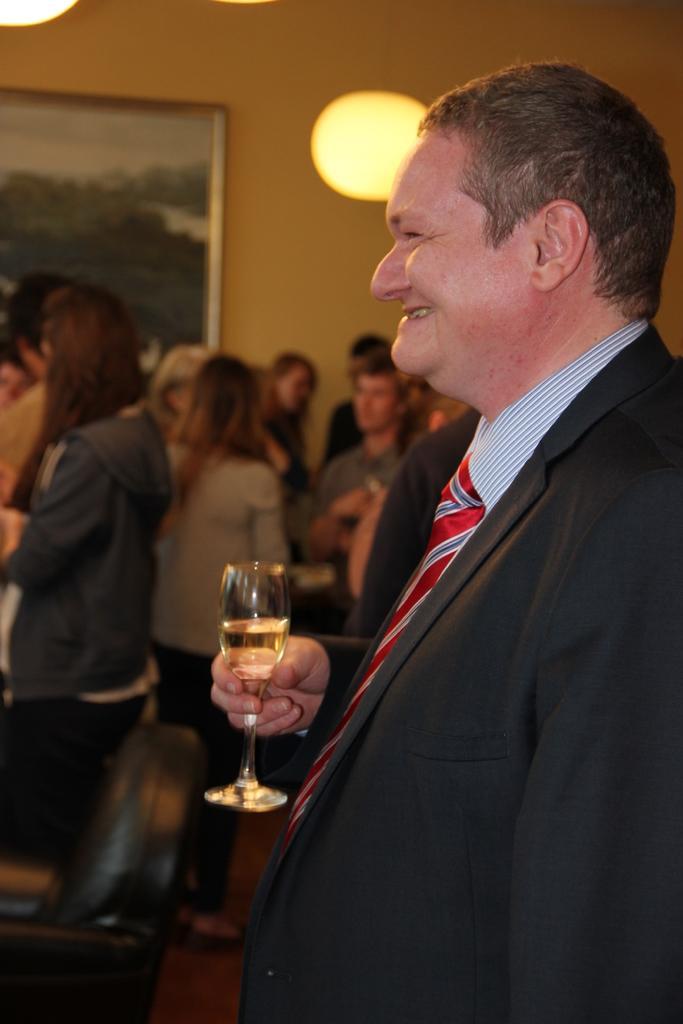How would you summarize this image in a sentence or two? In the given image we can see that, there are many people. This person is catching a wine glass in his hand. there is a photo frame stick on wall. This is a light. 